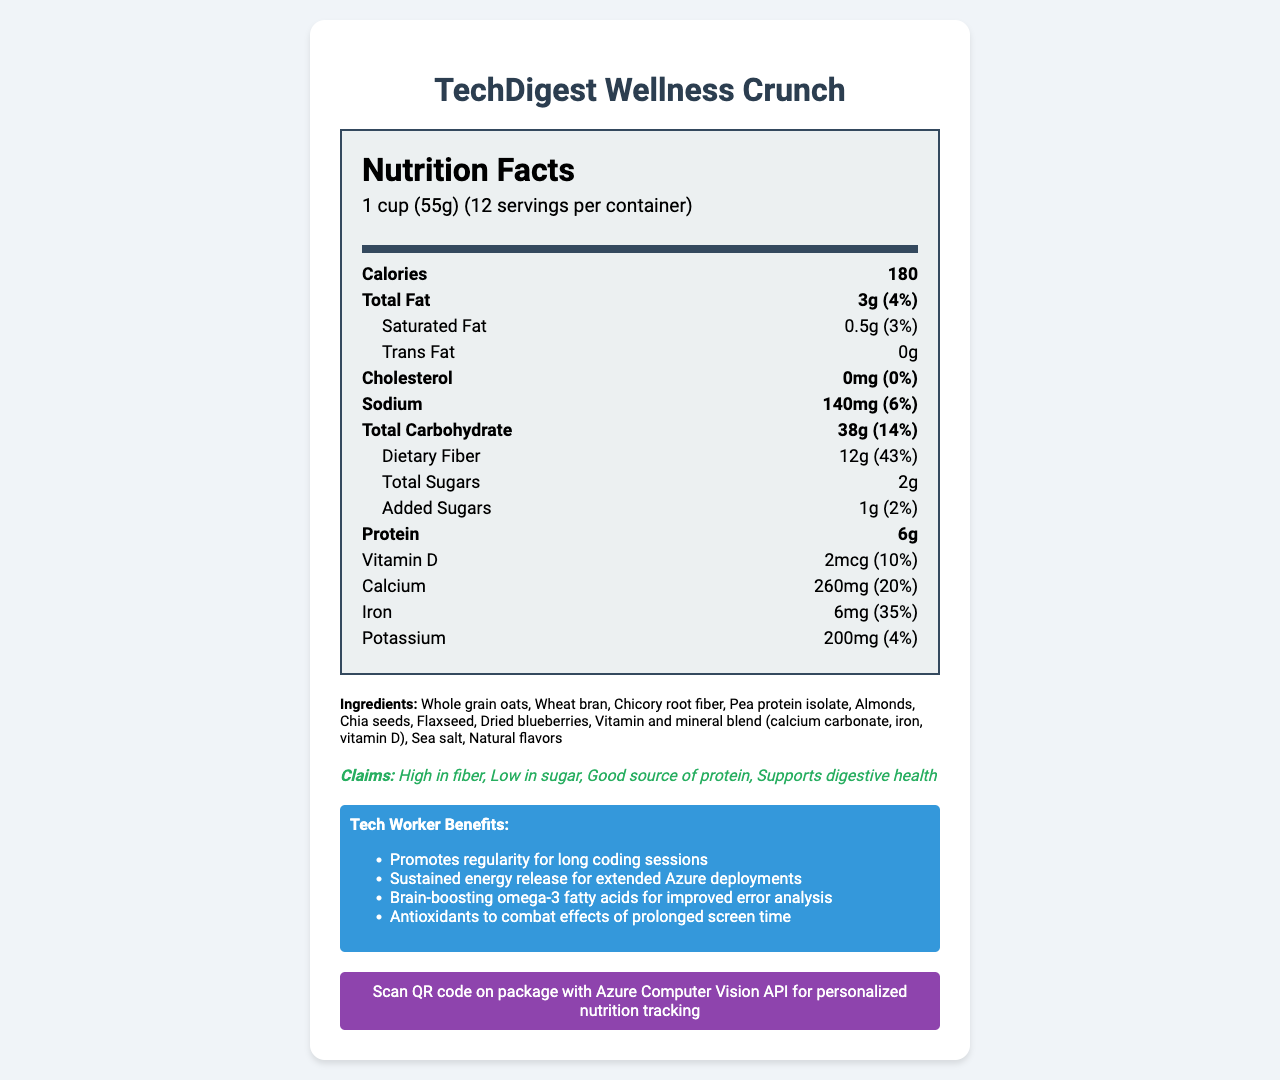how many calories are there per serving? The document lists calories per serving under the “Calories” section as 180.
Answer: 180 what is the serving size? The serving size is indicated in the document as “1 cup (55g)”.
Answer: 1 cup (55g) how much dietary fiber is in one serving? The document's "Dietary Fiber" section shows there are 12g of dietary fiber per serving.
Answer: 12g does the product contain any trans fat? The "Trans Fat" section indicates that there is 0g of trans fat.
Answer: No how many servings are there in the whole container? The document mentions that there are 12 servings per container.
Answer: 12 what are the main benefits for tech workers as stated in the document? These benefits are listed under the "Tech Worker Benefits" section.
Answer: Promotes regularity for long coding sessions, Sustained energy release for extended Azure deployments, Brain-boosting omega-3 fatty acids for improved error analysis, Antioxidants to combat effects of prolonged screen time what ingredients are included in the cereal? A. Whole grain oats, Wheat bran, Chicory root fiber B. Pea protein isolate, Almonds, Chia seeds, Flaxseed C. Dried blueberries, Sea salt, Natural flavors D. All of the above The ingredients list includes all the options mentioned.
Answer: D which vitamin is included in the cereal's vitamin and mineral blend? A. Vitamin A B. Vitamin C C. Vitamin D D. Vitamin B12 The "ingredients" section includes "Vitamin and mineral blend (calcium carbonate, iron, vitamin D)," indicating that Vitamin D is present.
Answer: C is the product low in sugar? One of the claim statements explicitly says "Low in sugar."
Answer: Yes describe the main idea of this document. The document presents the detailed nutritional information of the cereal including serving size, ingredients, claim statements, and benefits targeted at tech workers.
Answer: This document provides the nutrition facts for "TechDigest Wellness Crunch," a low-sugar, high-fiber cereal tailored for sedentary tech workers. It outlines the nutritional values per serving, ingredient list, and specific benefits for tech workers, along with a feature for Azure integration. what is the total amount of added sugars in all servings combined? The document only provides the added sugars per serving (1g), not the total for all servings combined.
Answer: Not enough information 